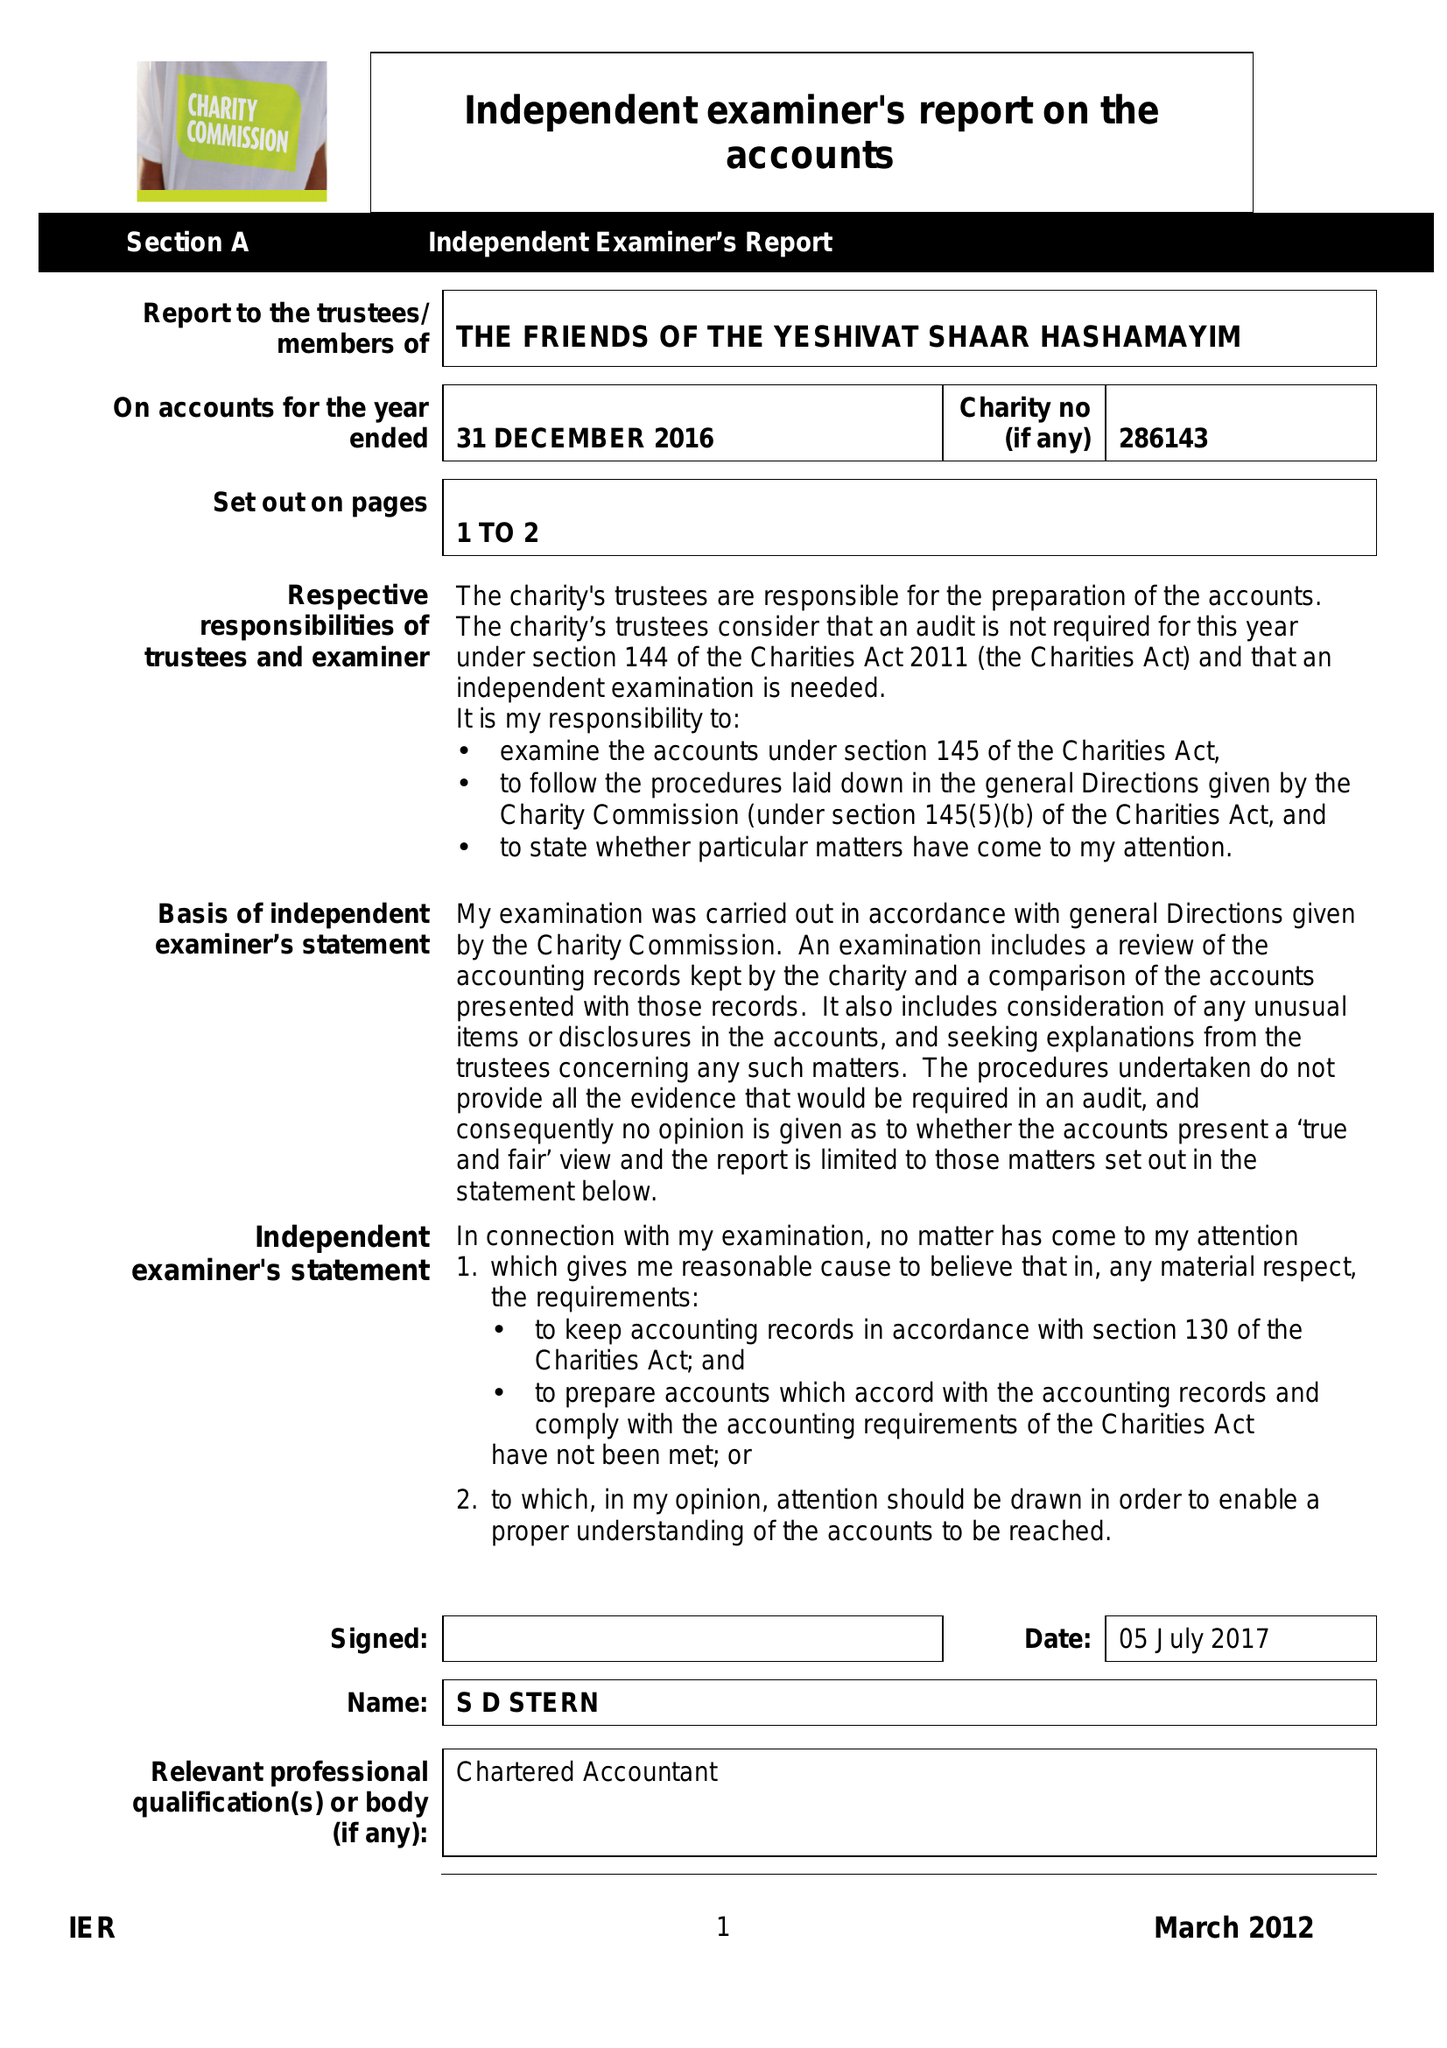What is the value for the address__street_line?
Answer the question using a single word or phrase. 12 DUNSTAN ROAD 